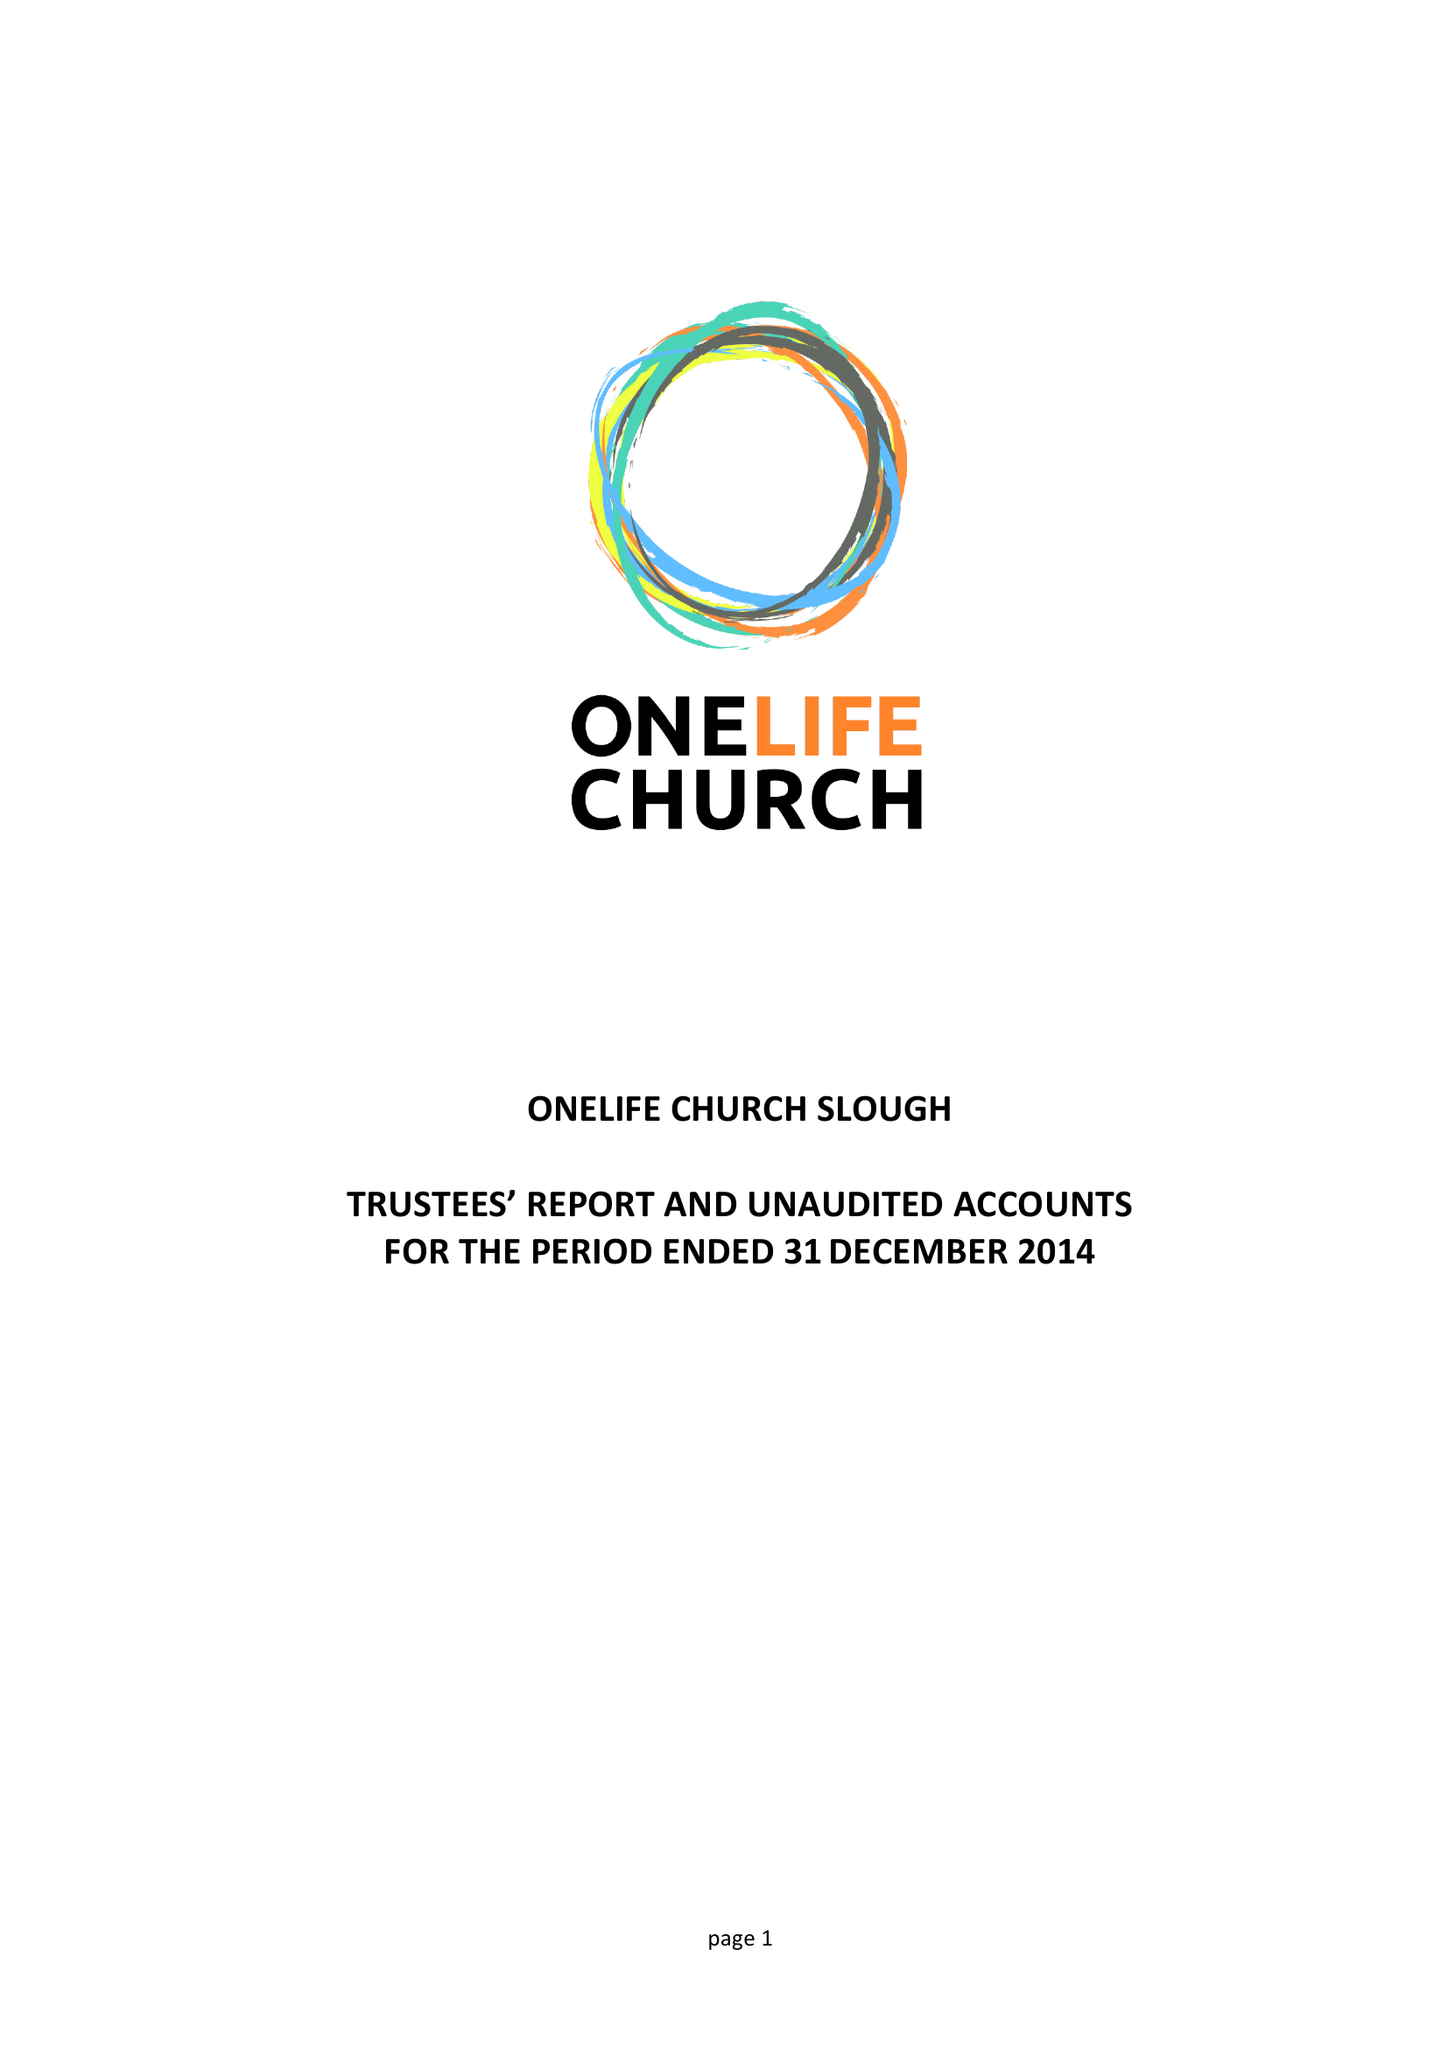What is the value for the charity_name?
Answer the question using a single word or phrase. Onelife Church Slough 